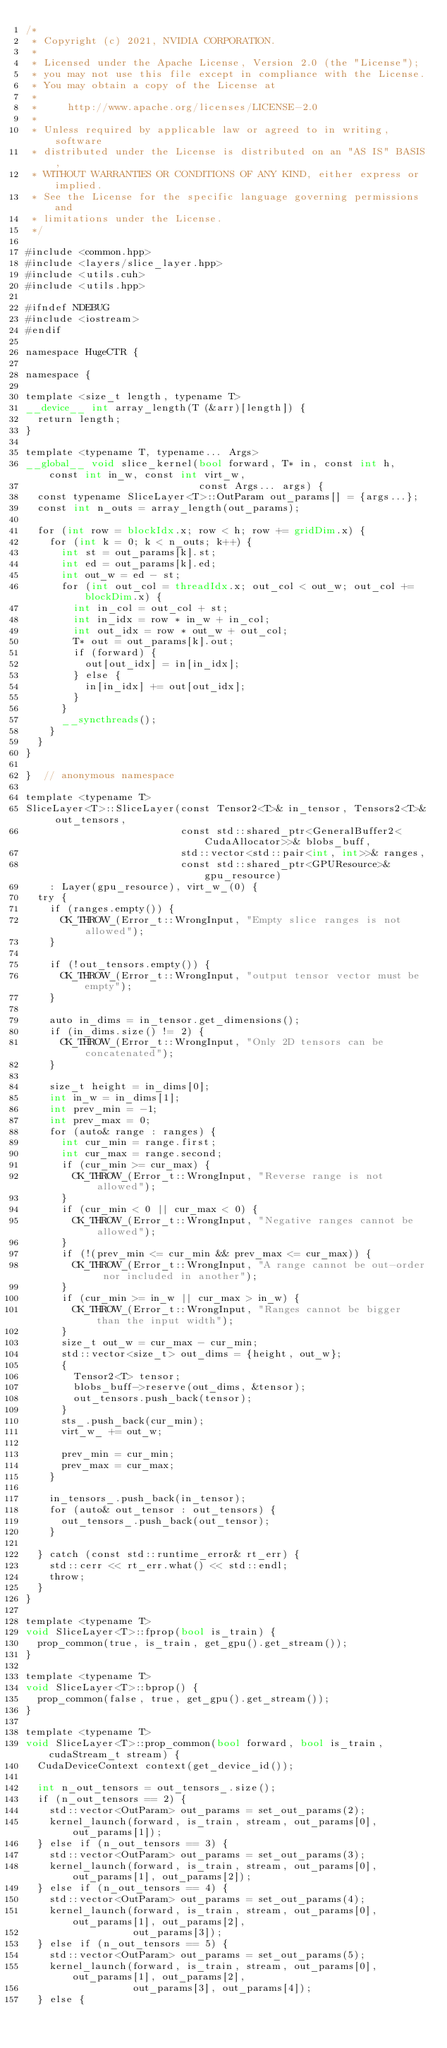Convert code to text. <code><loc_0><loc_0><loc_500><loc_500><_Cuda_>/*
 * Copyright (c) 2021, NVIDIA CORPORATION.
 *
 * Licensed under the Apache License, Version 2.0 (the "License");
 * you may not use this file except in compliance with the License.
 * You may obtain a copy of the License at
 *
 *     http://www.apache.org/licenses/LICENSE-2.0
 *
 * Unless required by applicable law or agreed to in writing, software
 * distributed under the License is distributed on an "AS IS" BASIS,
 * WITHOUT WARRANTIES OR CONDITIONS OF ANY KIND, either express or implied.
 * See the License for the specific language governing permissions and
 * limitations under the License.
 */

#include <common.hpp>
#include <layers/slice_layer.hpp>
#include <utils.cuh>
#include <utils.hpp>

#ifndef NDEBUG
#include <iostream>
#endif

namespace HugeCTR {

namespace {

template <size_t length, typename T>
__device__ int array_length(T (&arr)[length]) {
  return length;
}

template <typename T, typename... Args>
__global__ void slice_kernel(bool forward, T* in, const int h, const int in_w, const int virt_w,
                             const Args... args) {
  const typename SliceLayer<T>::OutParam out_params[] = {args...};
  const int n_outs = array_length(out_params);

  for (int row = blockIdx.x; row < h; row += gridDim.x) {
    for (int k = 0; k < n_outs; k++) {
      int st = out_params[k].st;
      int ed = out_params[k].ed;
      int out_w = ed - st;
      for (int out_col = threadIdx.x; out_col < out_w; out_col += blockDim.x) {
        int in_col = out_col + st;
        int in_idx = row * in_w + in_col;
        int out_idx = row * out_w + out_col;
        T* out = out_params[k].out;
        if (forward) {
          out[out_idx] = in[in_idx];
        } else {
          in[in_idx] += out[out_idx];
        }
      }
      __syncthreads();
    }
  }
}

}  // anonymous namespace

template <typename T>
SliceLayer<T>::SliceLayer(const Tensor2<T>& in_tensor, Tensors2<T>& out_tensors,
                          const std::shared_ptr<GeneralBuffer2<CudaAllocator>>& blobs_buff,
                          std::vector<std::pair<int, int>>& ranges,
                          const std::shared_ptr<GPUResource>& gpu_resource)
    : Layer(gpu_resource), virt_w_(0) {
  try {
    if (ranges.empty()) {
      CK_THROW_(Error_t::WrongInput, "Empty slice ranges is not allowed");
    }

    if (!out_tensors.empty()) {
      CK_THROW_(Error_t::WrongInput, "output tensor vector must be empty");
    }

    auto in_dims = in_tensor.get_dimensions();
    if (in_dims.size() != 2) {
      CK_THROW_(Error_t::WrongInput, "Only 2D tensors can be concatenated");
    }

    size_t height = in_dims[0];
    int in_w = in_dims[1];
    int prev_min = -1;
    int prev_max = 0;
    for (auto& range : ranges) {
      int cur_min = range.first;
      int cur_max = range.second;
      if (cur_min >= cur_max) {
        CK_THROW_(Error_t::WrongInput, "Reverse range is not allowed");
      }
      if (cur_min < 0 || cur_max < 0) {
        CK_THROW_(Error_t::WrongInput, "Negative ranges cannot be allowed");
      }
      if (!(prev_min <= cur_min && prev_max <= cur_max)) {
        CK_THROW_(Error_t::WrongInput, "A range cannot be out-order nor included in another");
      }
      if (cur_min >= in_w || cur_max > in_w) {
        CK_THROW_(Error_t::WrongInput, "Ranges cannot be bigger than the input width");
      }
      size_t out_w = cur_max - cur_min;
      std::vector<size_t> out_dims = {height, out_w};
      {
        Tensor2<T> tensor;
        blobs_buff->reserve(out_dims, &tensor);
        out_tensors.push_back(tensor);
      }
      sts_.push_back(cur_min);
      virt_w_ += out_w;

      prev_min = cur_min;
      prev_max = cur_max;
    }

    in_tensors_.push_back(in_tensor);
    for (auto& out_tensor : out_tensors) {
      out_tensors_.push_back(out_tensor);
    }

  } catch (const std::runtime_error& rt_err) {
    std::cerr << rt_err.what() << std::endl;
    throw;
  }
}

template <typename T>
void SliceLayer<T>::fprop(bool is_train) {
  prop_common(true, is_train, get_gpu().get_stream());
}

template <typename T>
void SliceLayer<T>::bprop() {
  prop_common(false, true, get_gpu().get_stream());
}

template <typename T>
void SliceLayer<T>::prop_common(bool forward, bool is_train, cudaStream_t stream) {
  CudaDeviceContext context(get_device_id());

  int n_out_tensors = out_tensors_.size();
  if (n_out_tensors == 2) {
    std::vector<OutParam> out_params = set_out_params(2);
    kernel_launch(forward, is_train, stream, out_params[0], out_params[1]);
  } else if (n_out_tensors == 3) {
    std::vector<OutParam> out_params = set_out_params(3);
    kernel_launch(forward, is_train, stream, out_params[0], out_params[1], out_params[2]);
  } else if (n_out_tensors == 4) {
    std::vector<OutParam> out_params = set_out_params(4);
    kernel_launch(forward, is_train, stream, out_params[0], out_params[1], out_params[2],
                  out_params[3]);
  } else if (n_out_tensors == 5) {
    std::vector<OutParam> out_params = set_out_params(5);
    kernel_launch(forward, is_train, stream, out_params[0], out_params[1], out_params[2],
                  out_params[3], out_params[4]);
  } else {</code> 